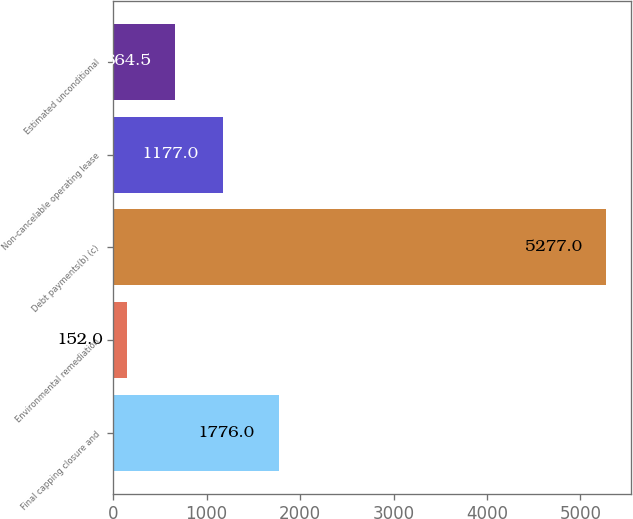<chart> <loc_0><loc_0><loc_500><loc_500><bar_chart><fcel>Final capping closure and<fcel>Environmental remediation<fcel>Debt payments(b) (c)<fcel>Non-cancelable operating lease<fcel>Estimated unconditional<nl><fcel>1776<fcel>152<fcel>5277<fcel>1177<fcel>664.5<nl></chart> 